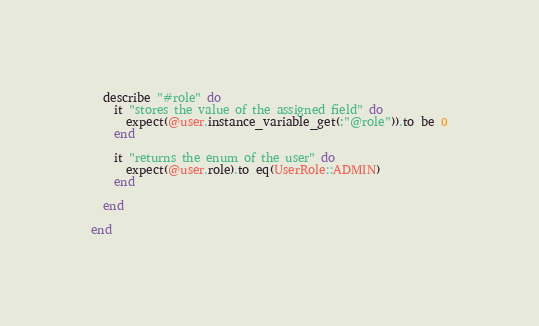<code> <loc_0><loc_0><loc_500><loc_500><_Ruby_>
  describe "#role" do
    it "stores the value of the assigned field" do 
      expect(@user.instance_variable_get(:"@role")).to be 0
    end
    
    it "returns the enum of the user" do
      expect(@user.role).to eq(UserRole::ADMIN)
    end

  end

end
</code> 